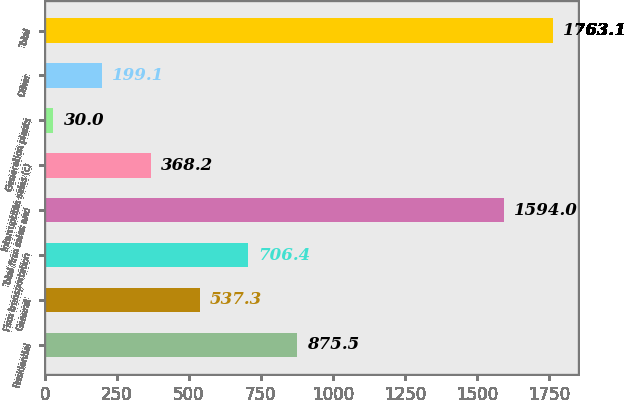Convert chart. <chart><loc_0><loc_0><loc_500><loc_500><bar_chart><fcel>Residential<fcel>General<fcel>Firm transportation<fcel>Total firm sales and<fcel>Interruptible sales (c)<fcel>Generation plants<fcel>Other<fcel>Total<nl><fcel>875.5<fcel>537.3<fcel>706.4<fcel>1594<fcel>368.2<fcel>30<fcel>199.1<fcel>1763.1<nl></chart> 